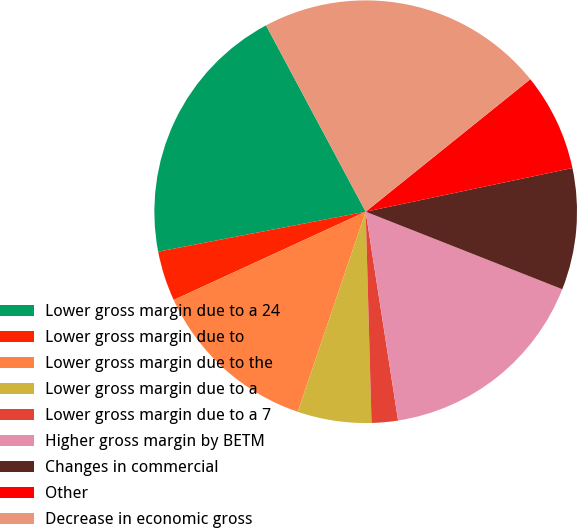<chart> <loc_0><loc_0><loc_500><loc_500><pie_chart><fcel>Lower gross margin due to a 24<fcel>Lower gross margin due to<fcel>Lower gross margin due to the<fcel>Lower gross margin due to a<fcel>Lower gross margin due to a 7<fcel>Higher gross margin by BETM<fcel>Changes in commercial<fcel>Other<fcel>Decrease in economic gross<nl><fcel>20.21%<fcel>3.83%<fcel>12.93%<fcel>5.65%<fcel>2.01%<fcel>16.57%<fcel>9.29%<fcel>7.47%<fcel>22.03%<nl></chart> 